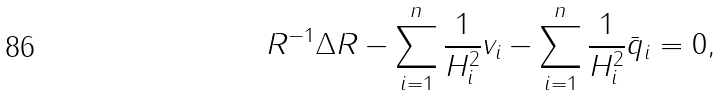<formula> <loc_0><loc_0><loc_500><loc_500>R ^ { - 1 } \Delta R - \sum _ { i = 1 } ^ { n } \frac { 1 } { H _ { i } ^ { 2 } } v _ { i } - \sum _ { i = 1 } ^ { n } \frac { 1 } { H _ { i } ^ { 2 } } \bar { q } _ { i } = 0 ,</formula> 